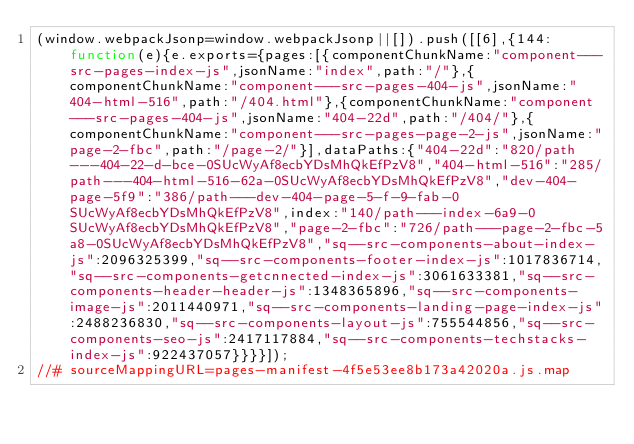<code> <loc_0><loc_0><loc_500><loc_500><_JavaScript_>(window.webpackJsonp=window.webpackJsonp||[]).push([[6],{144:function(e){e.exports={pages:[{componentChunkName:"component---src-pages-index-js",jsonName:"index",path:"/"},{componentChunkName:"component---src-pages-404-js",jsonName:"404-html-516",path:"/404.html"},{componentChunkName:"component---src-pages-404-js",jsonName:"404-22d",path:"/404/"},{componentChunkName:"component---src-pages-page-2-js",jsonName:"page-2-fbc",path:"/page-2/"}],dataPaths:{"404-22d":"820/path---404-22-d-bce-0SUcWyAf8ecbYDsMhQkEfPzV8","404-html-516":"285/path---404-html-516-62a-0SUcWyAf8ecbYDsMhQkEfPzV8","dev-404-page-5f9":"386/path---dev-404-page-5-f-9-fab-0SUcWyAf8ecbYDsMhQkEfPzV8",index:"140/path---index-6a9-0SUcWyAf8ecbYDsMhQkEfPzV8","page-2-fbc":"726/path---page-2-fbc-5a8-0SUcWyAf8ecbYDsMhQkEfPzV8","sq--src-components-about-index-js":2096325399,"sq--src-components-footer-index-js":1017836714,"sq--src-components-getcnnected-index-js":3061633381,"sq--src-components-header-header-js":1348365896,"sq--src-components-image-js":2011440971,"sq--src-components-landing-page-index-js":2488236830,"sq--src-components-layout-js":755544856,"sq--src-components-seo-js":2417117884,"sq--src-components-techstacks-index-js":922437057}}}}]);
//# sourceMappingURL=pages-manifest-4f5e53ee8b173a42020a.js.map</code> 